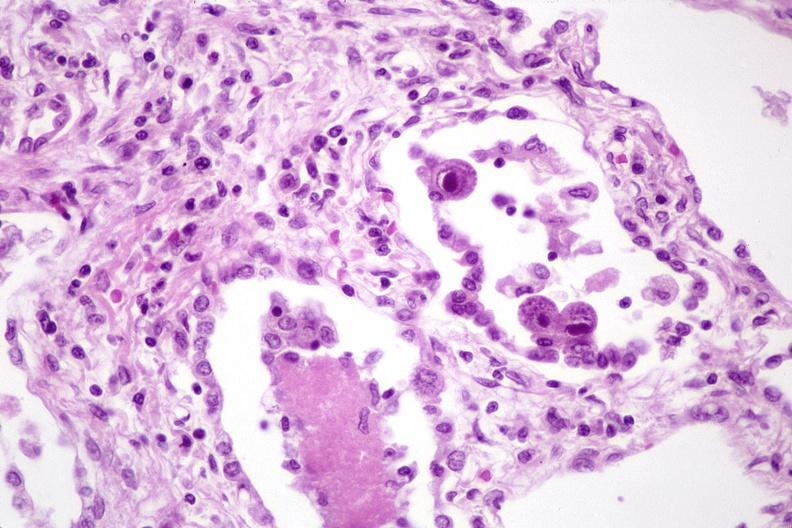where is this?
Answer the question using a single word or phrase. Lung 